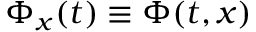<formula> <loc_0><loc_0><loc_500><loc_500>\Phi _ { x } ( t ) \equiv \Phi ( t , x )</formula> 